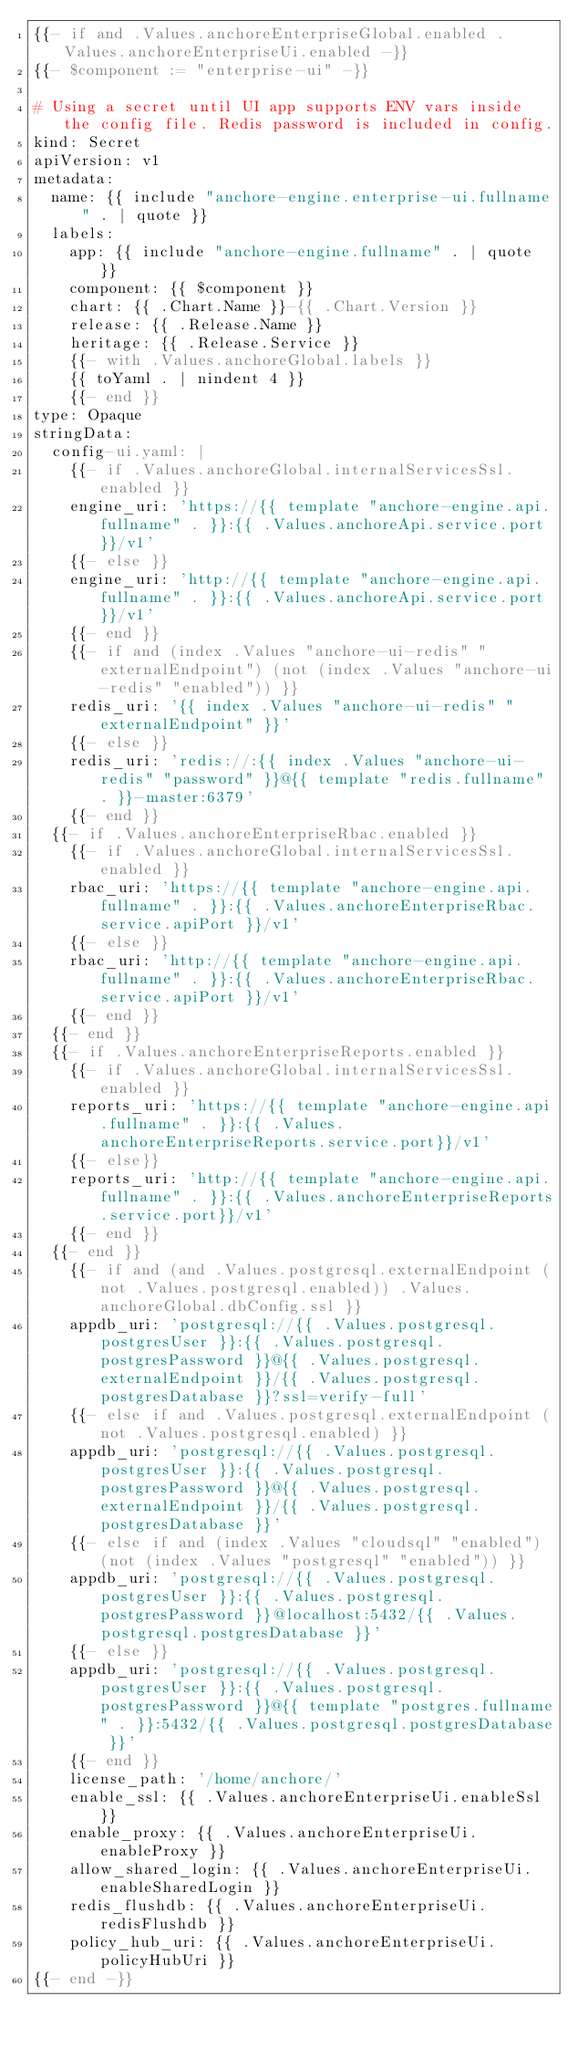Convert code to text. <code><loc_0><loc_0><loc_500><loc_500><_YAML_>{{- if and .Values.anchoreEnterpriseGlobal.enabled .Values.anchoreEnterpriseUi.enabled -}}
{{- $component := "enterprise-ui" -}}

# Using a secret until UI app supports ENV vars inside the config file. Redis password is included in config.
kind: Secret
apiVersion: v1
metadata:
  name: {{ include "anchore-engine.enterprise-ui.fullname" . | quote }}
  labels:
    app: {{ include "anchore-engine.fullname" . | quote }}
    component: {{ $component }}
    chart: {{ .Chart.Name }}-{{ .Chart.Version }}
    release: {{ .Release.Name }}
    heritage: {{ .Release.Service }}
    {{- with .Values.anchoreGlobal.labels }}
    {{ toYaml . | nindent 4 }}
    {{- end }}
type: Opaque
stringData:
  config-ui.yaml: |
    {{- if .Values.anchoreGlobal.internalServicesSsl.enabled }}
    engine_uri: 'https://{{ template "anchore-engine.api.fullname" . }}:{{ .Values.anchoreApi.service.port }}/v1'
    {{- else }}
    engine_uri: 'http://{{ template "anchore-engine.api.fullname" . }}:{{ .Values.anchoreApi.service.port }}/v1'
    {{- end }}
    {{- if and (index .Values "anchore-ui-redis" "externalEndpoint") (not (index .Values "anchore-ui-redis" "enabled")) }}
    redis_uri: '{{ index .Values "anchore-ui-redis" "externalEndpoint" }}'
    {{- else }}
    redis_uri: 'redis://:{{ index .Values "anchore-ui-redis" "password" }}@{{ template "redis.fullname" . }}-master:6379'
    {{- end }}
  {{- if .Values.anchoreEnterpriseRbac.enabled }}
    {{- if .Values.anchoreGlobal.internalServicesSsl.enabled }}
    rbac_uri: 'https://{{ template "anchore-engine.api.fullname" . }}:{{ .Values.anchoreEnterpriseRbac.service.apiPort }}/v1'
    {{- else }}
    rbac_uri: 'http://{{ template "anchore-engine.api.fullname" . }}:{{ .Values.anchoreEnterpriseRbac.service.apiPort }}/v1'
    {{- end }}
  {{- end }}
  {{- if .Values.anchoreEnterpriseReports.enabled }}
    {{- if .Values.anchoreGlobal.internalServicesSsl.enabled }}
    reports_uri: 'https://{{ template "anchore-engine.api.fullname" . }}:{{ .Values.anchoreEnterpriseReports.service.port}}/v1'
    {{- else}}
    reports_uri: 'http://{{ template "anchore-engine.api.fullname" . }}:{{ .Values.anchoreEnterpriseReports.service.port}}/v1'
    {{- end }}
  {{- end }}
    {{- if and (and .Values.postgresql.externalEndpoint (not .Values.postgresql.enabled)) .Values.anchoreGlobal.dbConfig.ssl }}
    appdb_uri: 'postgresql://{{ .Values.postgresql.postgresUser }}:{{ .Values.postgresql.postgresPassword }}@{{ .Values.postgresql.externalEndpoint }}/{{ .Values.postgresql.postgresDatabase }}?ssl=verify-full'
    {{- else if and .Values.postgresql.externalEndpoint (not .Values.postgresql.enabled) }}
    appdb_uri: 'postgresql://{{ .Values.postgresql.postgresUser }}:{{ .Values.postgresql.postgresPassword }}@{{ .Values.postgresql.externalEndpoint }}/{{ .Values.postgresql.postgresDatabase }}'
    {{- else if and (index .Values "cloudsql" "enabled") (not (index .Values "postgresql" "enabled")) }}
    appdb_uri: 'postgresql://{{ .Values.postgresql.postgresUser }}:{{ .Values.postgresql.postgresPassword }}@localhost:5432/{{ .Values.postgresql.postgresDatabase }}'
    {{- else }}
    appdb_uri: 'postgresql://{{ .Values.postgresql.postgresUser }}:{{ .Values.postgresql.postgresPassword }}@{{ template "postgres.fullname" . }}:5432/{{ .Values.postgresql.postgresDatabase }}'
    {{- end }}
    license_path: '/home/anchore/'
    enable_ssl: {{ .Values.anchoreEnterpriseUi.enableSsl }}
    enable_proxy: {{ .Values.anchoreEnterpriseUi.enableProxy }}
    allow_shared_login: {{ .Values.anchoreEnterpriseUi.enableSharedLogin }}
    redis_flushdb: {{ .Values.anchoreEnterpriseUi.redisFlushdb }}
    policy_hub_uri: {{ .Values.anchoreEnterpriseUi.policyHubUri }}
{{- end -}}
</code> 